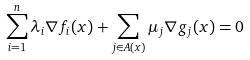Convert formula to latex. <formula><loc_0><loc_0><loc_500><loc_500>\sum _ { i = 1 } ^ { n } \lambda _ { i } \nabla f _ { i } ( x ) + \sum _ { j \in A ( x ) } \mu _ { j } \nabla g _ { j } ( x ) = 0</formula> 